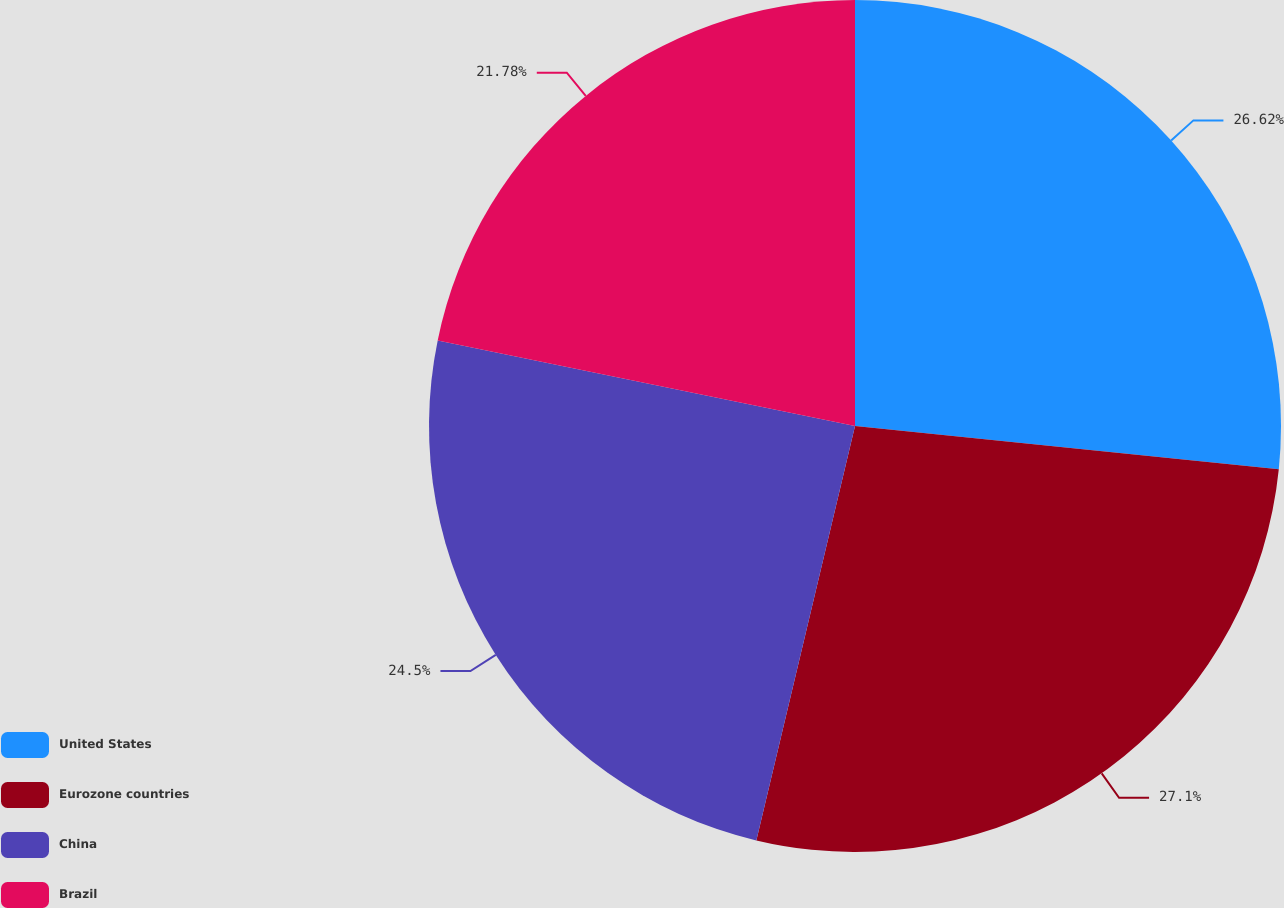Convert chart to OTSL. <chart><loc_0><loc_0><loc_500><loc_500><pie_chart><fcel>United States<fcel>Eurozone countries<fcel>China<fcel>Brazil<nl><fcel>26.62%<fcel>27.1%<fcel>24.5%<fcel>21.78%<nl></chart> 